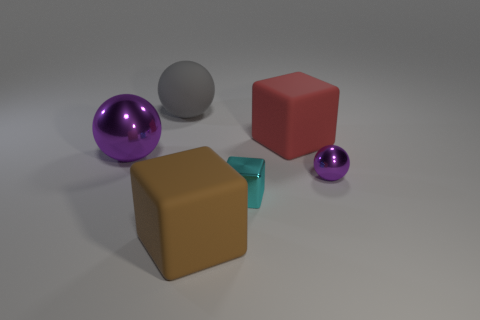Add 1 small objects. How many objects exist? 7 Subtract all cyan metal blocks. Subtract all small metal objects. How many objects are left? 3 Add 5 large metallic things. How many large metallic things are left? 6 Add 3 small blocks. How many small blocks exist? 4 Subtract 0 green cubes. How many objects are left? 6 